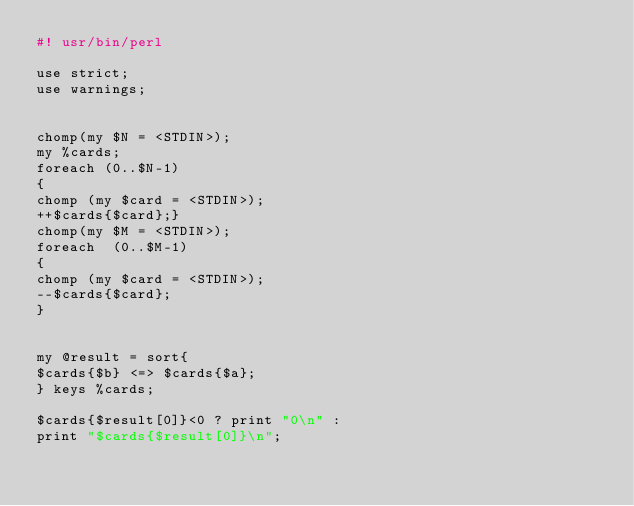<code> <loc_0><loc_0><loc_500><loc_500><_Perl_>#! usr/bin/perl

use strict;
use warnings;


chomp(my $N = <STDIN>);
my %cards;
foreach (0..$N-1)
{
chomp (my $card = <STDIN>);
++$cards{$card};}
chomp(my $M = <STDIN>);
foreach  (0..$M-1)
{
chomp (my $card = <STDIN>);
--$cards{$card};
}


my @result = sort{
$cards{$b} <=> $cards{$a};
} keys %cards;

$cards{$result[0]}<0 ? print "0\n" :
print "$cards{$result[0]}\n";
</code> 